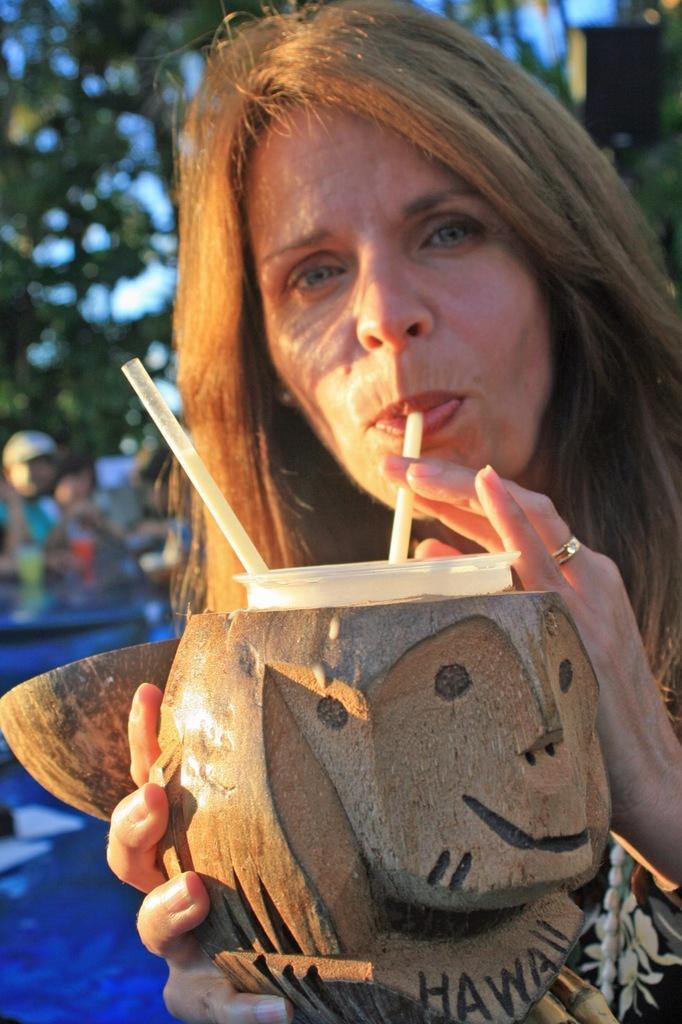Can you describe this image briefly? In this image, we can see a lady holding an object and is drinking a liquid. In the background, we can see a few people and some trees. 